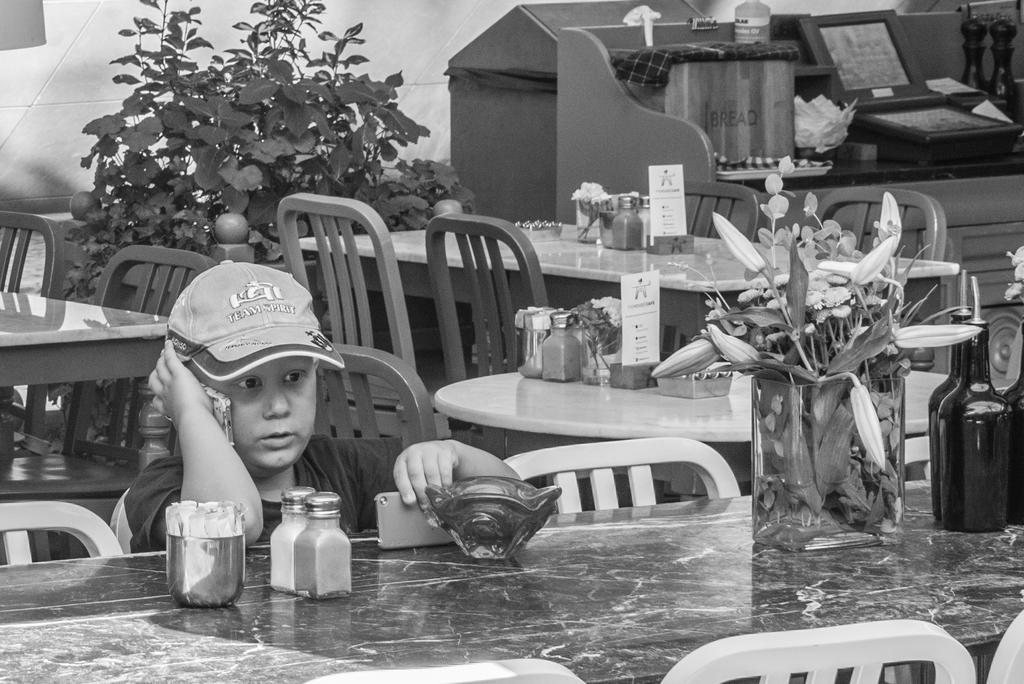Who is the main subject in the image? There is a boy in the image. What is the boy doing in the image? The boy is seated on a chair. What is the boy holding in his hand? The boy is holding a mobile in his hand. What can be seen on the table in the image? There are plants and flowers on the table. What type of muscle is visible on the boy's arm in the image? There is no muscle visible on the boy's arm in the image. How many pizzas are on the table in the image? There are no pizzas present in the image; it features plants and flowers on the table. 